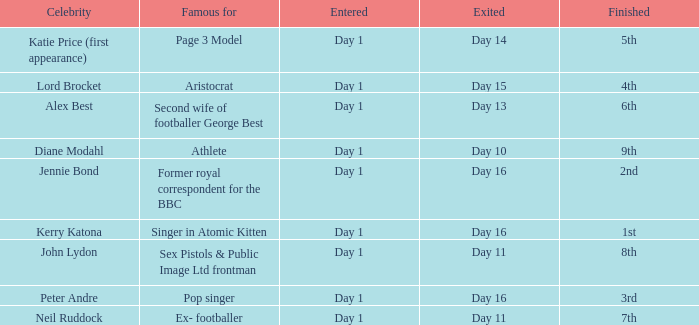Name the finished for exited day 13 6th. 